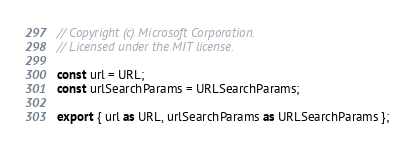Convert code to text. <code><loc_0><loc_0><loc_500><loc_500><_TypeScript_>// Copyright (c) Microsoft Corporation.
// Licensed under the MIT license.

const url = URL;
const urlSearchParams = URLSearchParams;

export { url as URL, urlSearchParams as URLSearchParams };
</code> 